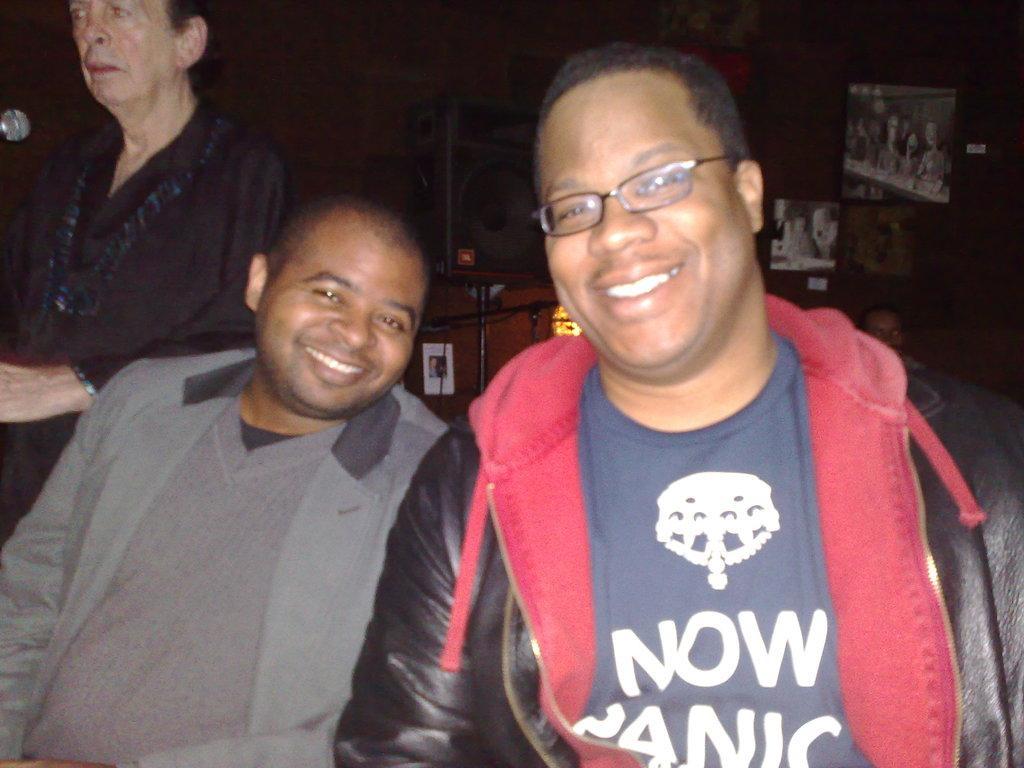How would you summarize this image in a sentence or two? This image is taken indoors. In the background there is a wall with a few picture frames and there are a few things and there is a man. On the left side of the image a man is standing and there is a mic. In the middle of the image there are two men and they are with smiling faces. 